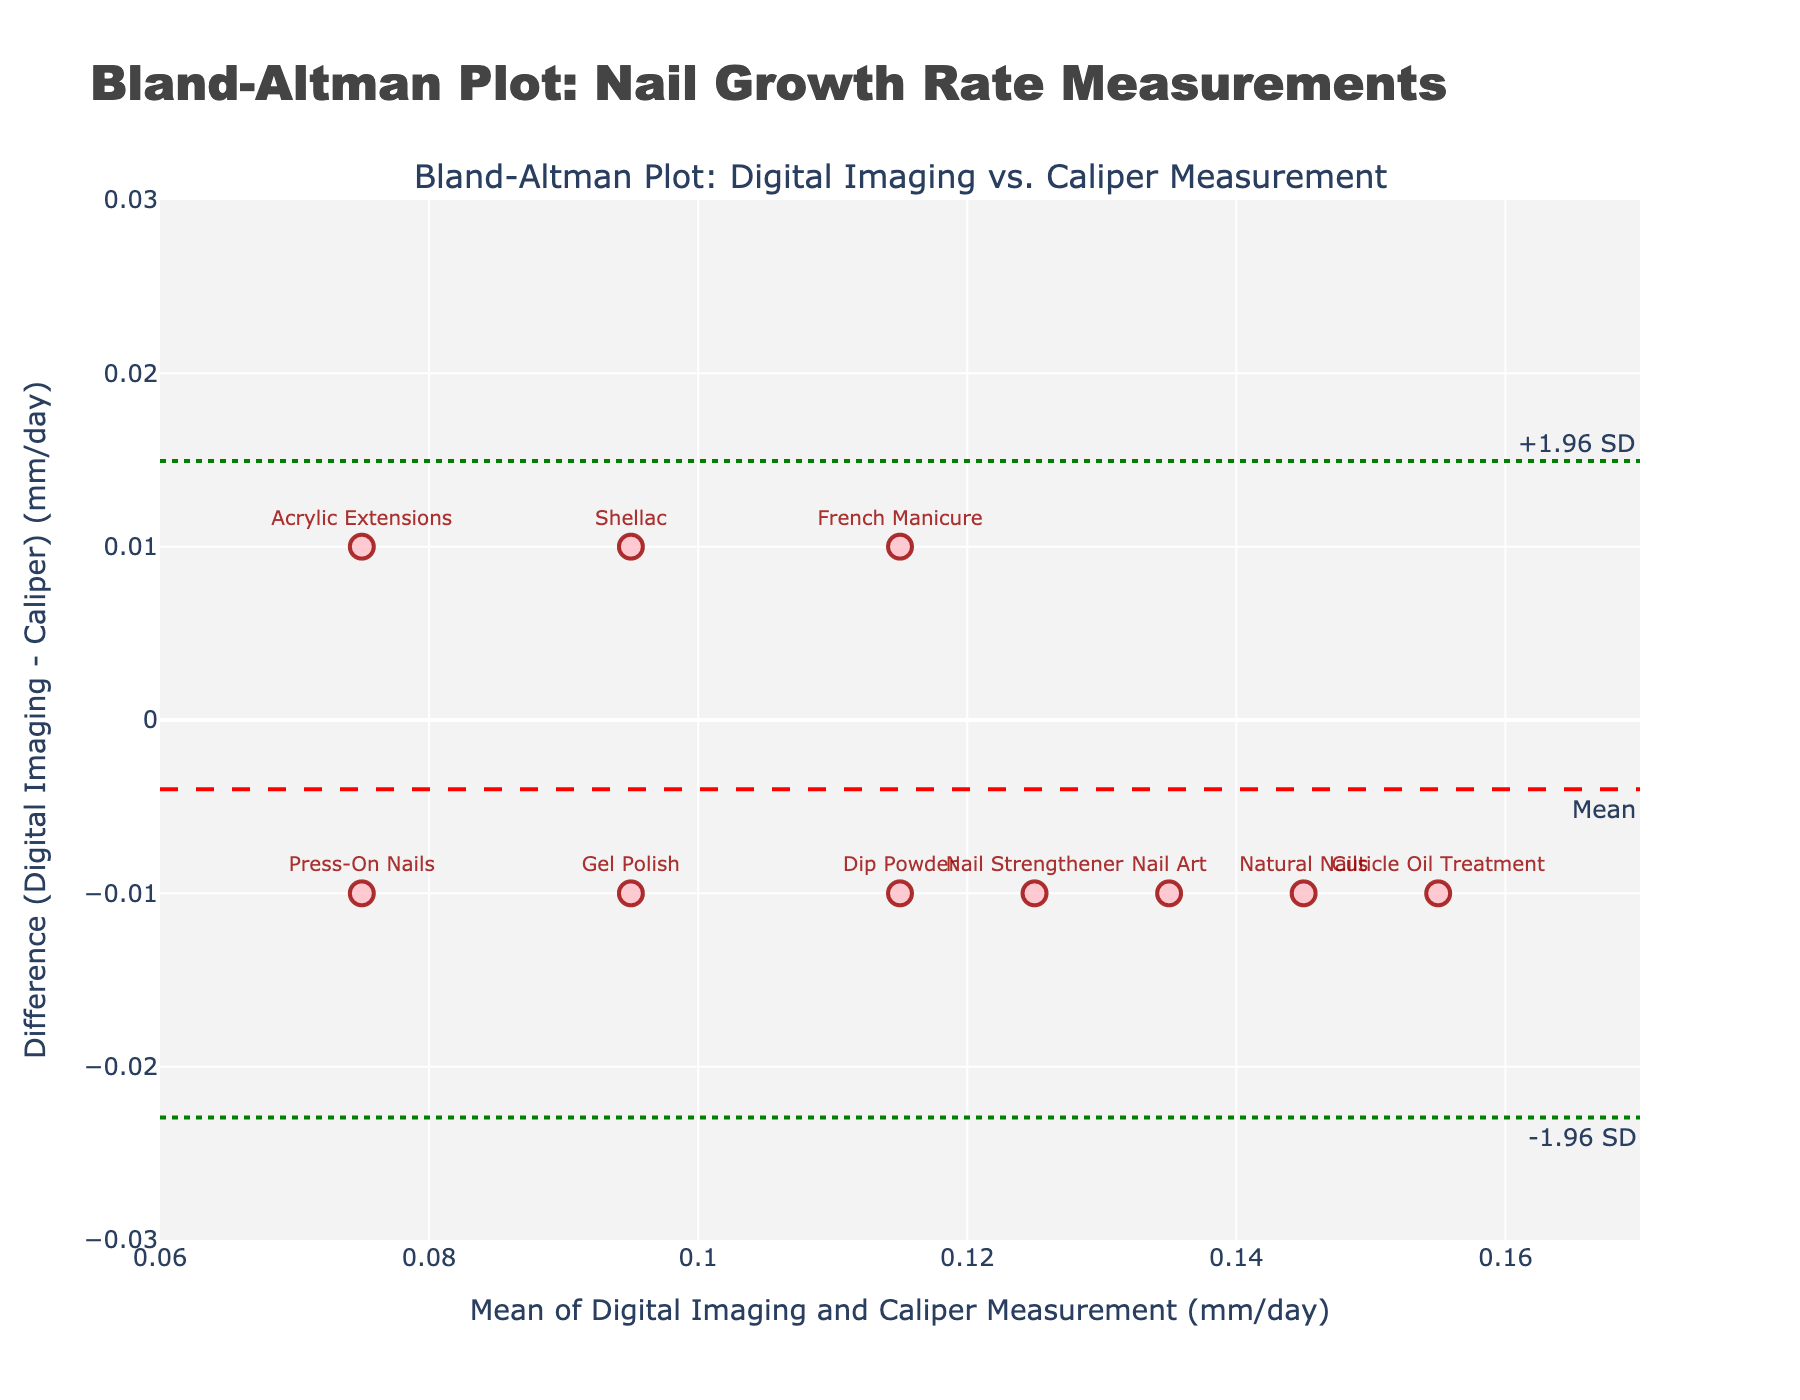What is the title of the plot? The title is found at the top of the plot.
Answer: Bland-Altman Plot: Nail Growth Rate Measurements What are the x-axis and y-axis labels? The x-axis and y-axis labels are located along the bottom and left sides of the plot, respectively.
Answer: Mean of Digital Imaging and Caliper Measurement (mm/day) and Difference (Digital Imaging - Caliper) (mm/day) What is the range of the x-axis? The x-axis range can be observed from the axis ticks.
Answer: 0.06 to 0.17 What is the range of the y-axis? The y-axis range can be seen from the axis ticks.
Answer: -0.03 to 0.03 How many data points are shown in the plot? Count the number of scatter points in the plot.
Answer: 10 Which method had the greatest difference between Digital Imaging and Caliper Measurement? Look at the scatter points to see which method has the highest position on the y-axis.
Answer: Cuticle Oil Treatment What is the average difference between Digital Imaging and Caliper Measurement across all methods? This can be inferred from the mean difference line, which is at y = 0.005.
Answer: 0.005 mm/day What are the upper and lower limits of agreement? These are marked by dotted lines on the plot.
Answer: +1.96 SD and -1.96 SD are approximately 0.021 and -0.011 Identify a method with a negative difference value. Find a point located below the y=0 line and read the label.
Answer: Shellac Are there any methods that have measurements falling outside the limits of agreement? Check to see if any points lie beyond the dotted lines representing +1.96 SD and -1.96 SD.
Answer: No 